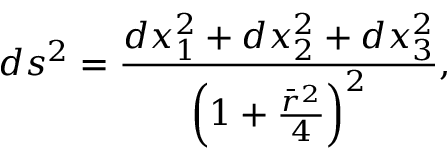<formula> <loc_0><loc_0><loc_500><loc_500>d s ^ { 2 } = \frac { d x _ { 1 } ^ { 2 } + d x _ { 2 } ^ { 2 } + d x _ { 3 } ^ { 2 } } { \left ( 1 + \frac { \bar { r } ^ { 2 } } { 4 } \right ) ^ { 2 } } ,</formula> 